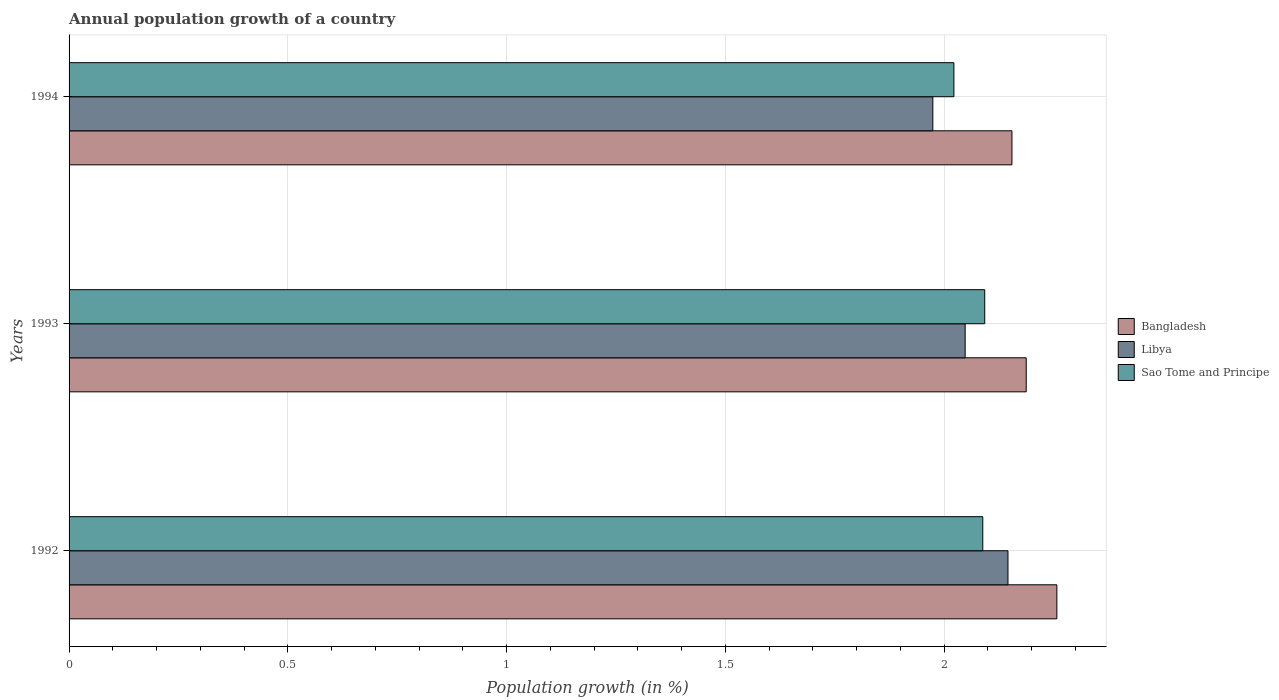How many different coloured bars are there?
Provide a succinct answer. 3. How many groups of bars are there?
Provide a short and direct response. 3. How many bars are there on the 1st tick from the top?
Keep it short and to the point. 3. How many bars are there on the 1st tick from the bottom?
Your answer should be compact. 3. What is the annual population growth in Sao Tome and Principe in 1993?
Provide a short and direct response. 2.09. Across all years, what is the maximum annual population growth in Sao Tome and Principe?
Your answer should be very brief. 2.09. Across all years, what is the minimum annual population growth in Sao Tome and Principe?
Offer a very short reply. 2.02. In which year was the annual population growth in Libya maximum?
Offer a terse response. 1992. In which year was the annual population growth in Libya minimum?
Your answer should be compact. 1994. What is the total annual population growth in Bangladesh in the graph?
Give a very brief answer. 6.6. What is the difference between the annual population growth in Libya in 1992 and that in 1993?
Keep it short and to the point. 0.1. What is the difference between the annual population growth in Bangladesh in 1994 and the annual population growth in Libya in 1992?
Your answer should be compact. 0.01. What is the average annual population growth in Sao Tome and Principe per year?
Your answer should be compact. 2.07. In the year 1994, what is the difference between the annual population growth in Bangladesh and annual population growth in Libya?
Make the answer very short. 0.18. What is the ratio of the annual population growth in Sao Tome and Principe in 1993 to that in 1994?
Your answer should be very brief. 1.03. Is the annual population growth in Bangladesh in 1993 less than that in 1994?
Keep it short and to the point. No. Is the difference between the annual population growth in Bangladesh in 1993 and 1994 greater than the difference between the annual population growth in Libya in 1993 and 1994?
Your answer should be very brief. No. What is the difference between the highest and the second highest annual population growth in Bangladesh?
Offer a terse response. 0.07. What is the difference between the highest and the lowest annual population growth in Bangladesh?
Give a very brief answer. 0.1. What does the 1st bar from the top in 1992 represents?
Make the answer very short. Sao Tome and Principe. What does the 3rd bar from the bottom in 1992 represents?
Your response must be concise. Sao Tome and Principe. How many bars are there?
Offer a terse response. 9. Are all the bars in the graph horizontal?
Offer a very short reply. Yes. How many years are there in the graph?
Provide a short and direct response. 3. How many legend labels are there?
Offer a terse response. 3. What is the title of the graph?
Offer a very short reply. Annual population growth of a country. What is the label or title of the X-axis?
Your answer should be compact. Population growth (in %). What is the label or title of the Y-axis?
Offer a terse response. Years. What is the Population growth (in %) of Bangladesh in 1992?
Your answer should be compact. 2.26. What is the Population growth (in %) in Libya in 1992?
Offer a very short reply. 2.15. What is the Population growth (in %) of Sao Tome and Principe in 1992?
Make the answer very short. 2.09. What is the Population growth (in %) in Bangladesh in 1993?
Your answer should be compact. 2.19. What is the Population growth (in %) of Libya in 1993?
Provide a short and direct response. 2.05. What is the Population growth (in %) of Sao Tome and Principe in 1993?
Your response must be concise. 2.09. What is the Population growth (in %) in Bangladesh in 1994?
Ensure brevity in your answer.  2.16. What is the Population growth (in %) of Libya in 1994?
Keep it short and to the point. 1.97. What is the Population growth (in %) in Sao Tome and Principe in 1994?
Offer a very short reply. 2.02. Across all years, what is the maximum Population growth (in %) in Bangladesh?
Provide a succinct answer. 2.26. Across all years, what is the maximum Population growth (in %) in Libya?
Provide a succinct answer. 2.15. Across all years, what is the maximum Population growth (in %) in Sao Tome and Principe?
Ensure brevity in your answer.  2.09. Across all years, what is the minimum Population growth (in %) in Bangladesh?
Your response must be concise. 2.16. Across all years, what is the minimum Population growth (in %) in Libya?
Ensure brevity in your answer.  1.97. Across all years, what is the minimum Population growth (in %) in Sao Tome and Principe?
Provide a short and direct response. 2.02. What is the total Population growth (in %) in Bangladesh in the graph?
Your answer should be compact. 6.6. What is the total Population growth (in %) of Libya in the graph?
Offer a very short reply. 6.17. What is the total Population growth (in %) in Sao Tome and Principe in the graph?
Offer a terse response. 6.2. What is the difference between the Population growth (in %) of Bangladesh in 1992 and that in 1993?
Your answer should be compact. 0.07. What is the difference between the Population growth (in %) in Libya in 1992 and that in 1993?
Give a very brief answer. 0.1. What is the difference between the Population growth (in %) in Sao Tome and Principe in 1992 and that in 1993?
Provide a short and direct response. -0. What is the difference between the Population growth (in %) in Bangladesh in 1992 and that in 1994?
Keep it short and to the point. 0.1. What is the difference between the Population growth (in %) in Libya in 1992 and that in 1994?
Keep it short and to the point. 0.17. What is the difference between the Population growth (in %) of Sao Tome and Principe in 1992 and that in 1994?
Ensure brevity in your answer.  0.07. What is the difference between the Population growth (in %) of Bangladesh in 1993 and that in 1994?
Your response must be concise. 0.03. What is the difference between the Population growth (in %) in Libya in 1993 and that in 1994?
Give a very brief answer. 0.07. What is the difference between the Population growth (in %) in Sao Tome and Principe in 1993 and that in 1994?
Your answer should be very brief. 0.07. What is the difference between the Population growth (in %) of Bangladesh in 1992 and the Population growth (in %) of Libya in 1993?
Your response must be concise. 0.21. What is the difference between the Population growth (in %) of Bangladesh in 1992 and the Population growth (in %) of Sao Tome and Principe in 1993?
Provide a succinct answer. 0.16. What is the difference between the Population growth (in %) of Libya in 1992 and the Population growth (in %) of Sao Tome and Principe in 1993?
Offer a terse response. 0.05. What is the difference between the Population growth (in %) in Bangladesh in 1992 and the Population growth (in %) in Libya in 1994?
Offer a terse response. 0.28. What is the difference between the Population growth (in %) in Bangladesh in 1992 and the Population growth (in %) in Sao Tome and Principe in 1994?
Give a very brief answer. 0.24. What is the difference between the Population growth (in %) in Libya in 1992 and the Population growth (in %) in Sao Tome and Principe in 1994?
Ensure brevity in your answer.  0.12. What is the difference between the Population growth (in %) in Bangladesh in 1993 and the Population growth (in %) in Libya in 1994?
Give a very brief answer. 0.21. What is the difference between the Population growth (in %) of Bangladesh in 1993 and the Population growth (in %) of Sao Tome and Principe in 1994?
Give a very brief answer. 0.17. What is the difference between the Population growth (in %) of Libya in 1993 and the Population growth (in %) of Sao Tome and Principe in 1994?
Make the answer very short. 0.03. What is the average Population growth (in %) in Bangladesh per year?
Give a very brief answer. 2.2. What is the average Population growth (in %) in Libya per year?
Offer a terse response. 2.06. What is the average Population growth (in %) in Sao Tome and Principe per year?
Make the answer very short. 2.07. In the year 1992, what is the difference between the Population growth (in %) of Bangladesh and Population growth (in %) of Libya?
Ensure brevity in your answer.  0.11. In the year 1992, what is the difference between the Population growth (in %) in Bangladesh and Population growth (in %) in Sao Tome and Principe?
Provide a succinct answer. 0.17. In the year 1992, what is the difference between the Population growth (in %) of Libya and Population growth (in %) of Sao Tome and Principe?
Ensure brevity in your answer.  0.06. In the year 1993, what is the difference between the Population growth (in %) in Bangladesh and Population growth (in %) in Libya?
Ensure brevity in your answer.  0.14. In the year 1993, what is the difference between the Population growth (in %) of Bangladesh and Population growth (in %) of Sao Tome and Principe?
Offer a very short reply. 0.09. In the year 1993, what is the difference between the Population growth (in %) in Libya and Population growth (in %) in Sao Tome and Principe?
Your answer should be very brief. -0.04. In the year 1994, what is the difference between the Population growth (in %) in Bangladesh and Population growth (in %) in Libya?
Offer a terse response. 0.18. In the year 1994, what is the difference between the Population growth (in %) in Bangladesh and Population growth (in %) in Sao Tome and Principe?
Your response must be concise. 0.13. In the year 1994, what is the difference between the Population growth (in %) in Libya and Population growth (in %) in Sao Tome and Principe?
Offer a terse response. -0.05. What is the ratio of the Population growth (in %) in Bangladesh in 1992 to that in 1993?
Your answer should be compact. 1.03. What is the ratio of the Population growth (in %) in Libya in 1992 to that in 1993?
Offer a very short reply. 1.05. What is the ratio of the Population growth (in %) of Sao Tome and Principe in 1992 to that in 1993?
Your response must be concise. 1. What is the ratio of the Population growth (in %) in Bangladesh in 1992 to that in 1994?
Your response must be concise. 1.05. What is the ratio of the Population growth (in %) in Libya in 1992 to that in 1994?
Your answer should be compact. 1.09. What is the ratio of the Population growth (in %) of Sao Tome and Principe in 1992 to that in 1994?
Your response must be concise. 1.03. What is the ratio of the Population growth (in %) in Bangladesh in 1993 to that in 1994?
Your answer should be compact. 1.02. What is the ratio of the Population growth (in %) in Libya in 1993 to that in 1994?
Keep it short and to the point. 1.04. What is the ratio of the Population growth (in %) in Sao Tome and Principe in 1993 to that in 1994?
Keep it short and to the point. 1.03. What is the difference between the highest and the second highest Population growth (in %) in Bangladesh?
Ensure brevity in your answer.  0.07. What is the difference between the highest and the second highest Population growth (in %) in Libya?
Give a very brief answer. 0.1. What is the difference between the highest and the second highest Population growth (in %) in Sao Tome and Principe?
Your answer should be compact. 0. What is the difference between the highest and the lowest Population growth (in %) of Bangladesh?
Give a very brief answer. 0.1. What is the difference between the highest and the lowest Population growth (in %) in Libya?
Your response must be concise. 0.17. What is the difference between the highest and the lowest Population growth (in %) of Sao Tome and Principe?
Keep it short and to the point. 0.07. 